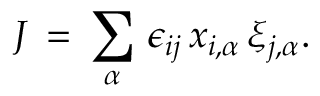<formula> <loc_0><loc_0><loc_500><loc_500>J \, = \, \sum _ { \alpha } \, \epsilon _ { i j } \, x _ { i , \alpha } \, \xi _ { j , \alpha } .</formula> 